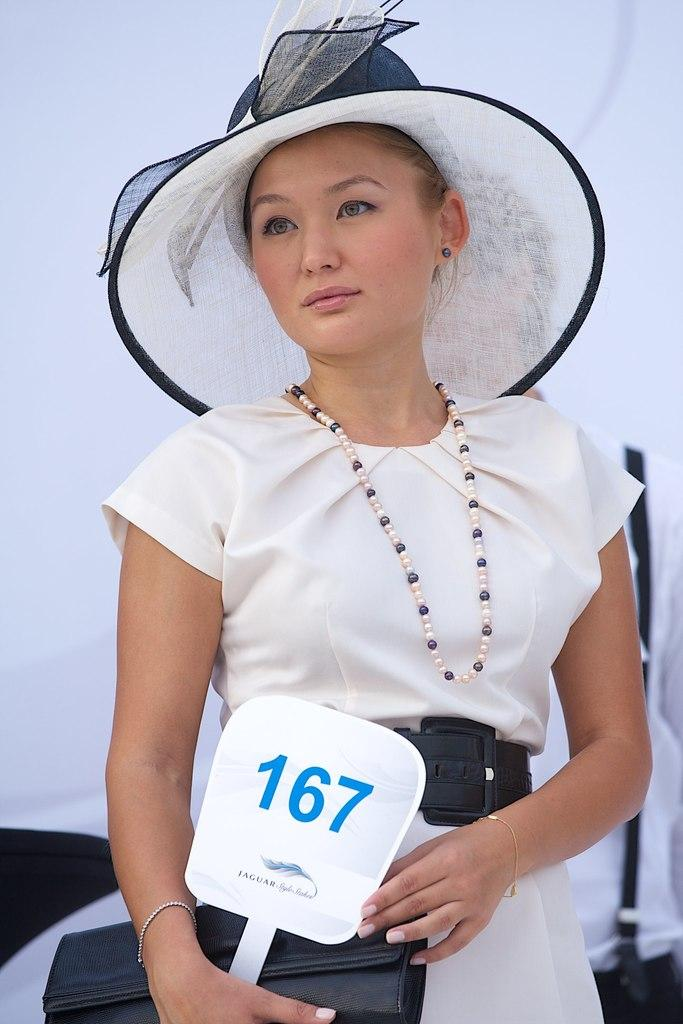Who is the main subject in the image? There is a woman in the image. What is the woman wearing? The woman is wearing a white dress, a cap, and a chain. What is the woman holding in her hands? The woman is holding a wallet and a card. What is the woman's profit from her recent business deal in the image? There is no information about a business deal or profit in the image. The woman is simply depicted wearing a white dress, cap, and chain, and holding a wallet and a card. 